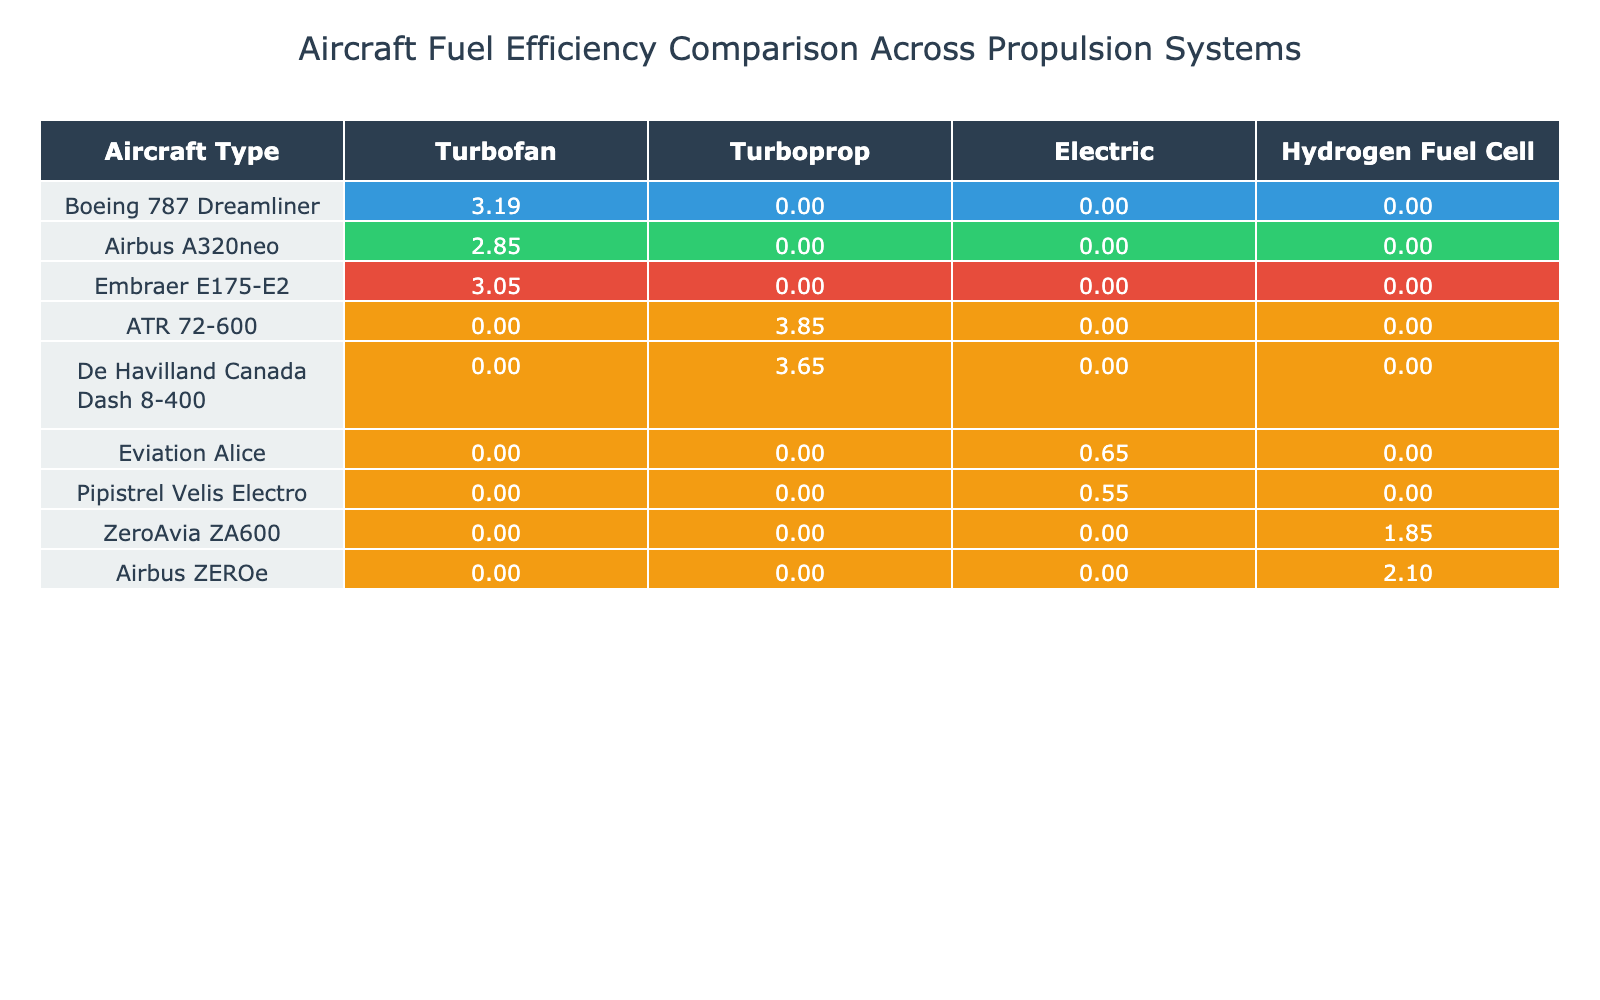What is the fuel efficiency of the Boeing 787 Dreamliner using a turbofan engine? The table indicates that the fuel efficiency of the Boeing 787 Dreamliner with a turbofan engine is 3.19.
Answer: 3.19 Which aircraft has the highest fuel efficiency in the turboprop category? The table shows that the ATR 72-600 has the highest fuel efficiency with a value of 3.85 among turboprop aircraft.
Answer: ATR 72-600 Does the Airbus A320neo feature any electric propulsion systems? According to the table, the Airbus A320neo does not have any values listed under the electric column, indicating it does not feature electric propulsion.
Answer: No What is the fuel efficiency difference between the Embraer E175-E2 and the Boeing 787 Dreamliner in the turbofan category? The fuel efficiency of the Embraer E175-E2 is 3.05 and that of the Boeing 787 Dreamliner is 3.19. The difference is calculated as 3.19 - 3.05 = 0.14.
Answer: 0.14 Which propulsion system does the Pipistrel Velis Electro use and what is its fuel efficiency? The Pipistrel Velis Electro uses an electric propulsion system, and its fuel efficiency is 0.55 according to the table.
Answer: Electric, 0.55 How many aircraft types are listed that utilize hydrogen fuel cell propulsion? The table indicates two aircraft types, ZeroAvia ZA600 and Airbus ZEROe, that utilize hydrogen fuel cell propulsion.
Answer: 2 What is the average fuel efficiency of turbofan engines across the listed aircraft? The turbofan aircraft listed, with efficiencies of 3.19 (Boeing 787 Dreamliner), 2.85 (Airbus A320neo), and 3.05 (Embraer E175-E2), have an average calculated as (3.19 + 2.85 + 3.05) / 3 = 3.03.
Answer: 3.03 Is there any aircraft listed with only electric propulsion and no other propulsion types? The table includes Eviation Alice and Pipistrel Velis Electro, which are shown to use electric propulsion exclusively, as their other propulsion types contain N/A values.
Answer: Yes What is the highest fuel efficiency recorded for any aircraft in the electric propulsion category? The highest fuel efficiency recorded for electric propulsion is 0.65 for the Eviation Alice, as shown in the table.
Answer: 0.65 Calculate the combined fuel efficiency of the De Havilland Canada Dash 8-400 and the ATR 72-600 in the turboprop category. The fuel efficiency of the De Havilland Canada Dash 8-400 is 3.65 and that of the ATR 72-600 is 3.85. Thus, combined, it is 3.65 + 3.85 = 7.50.
Answer: 7.50 